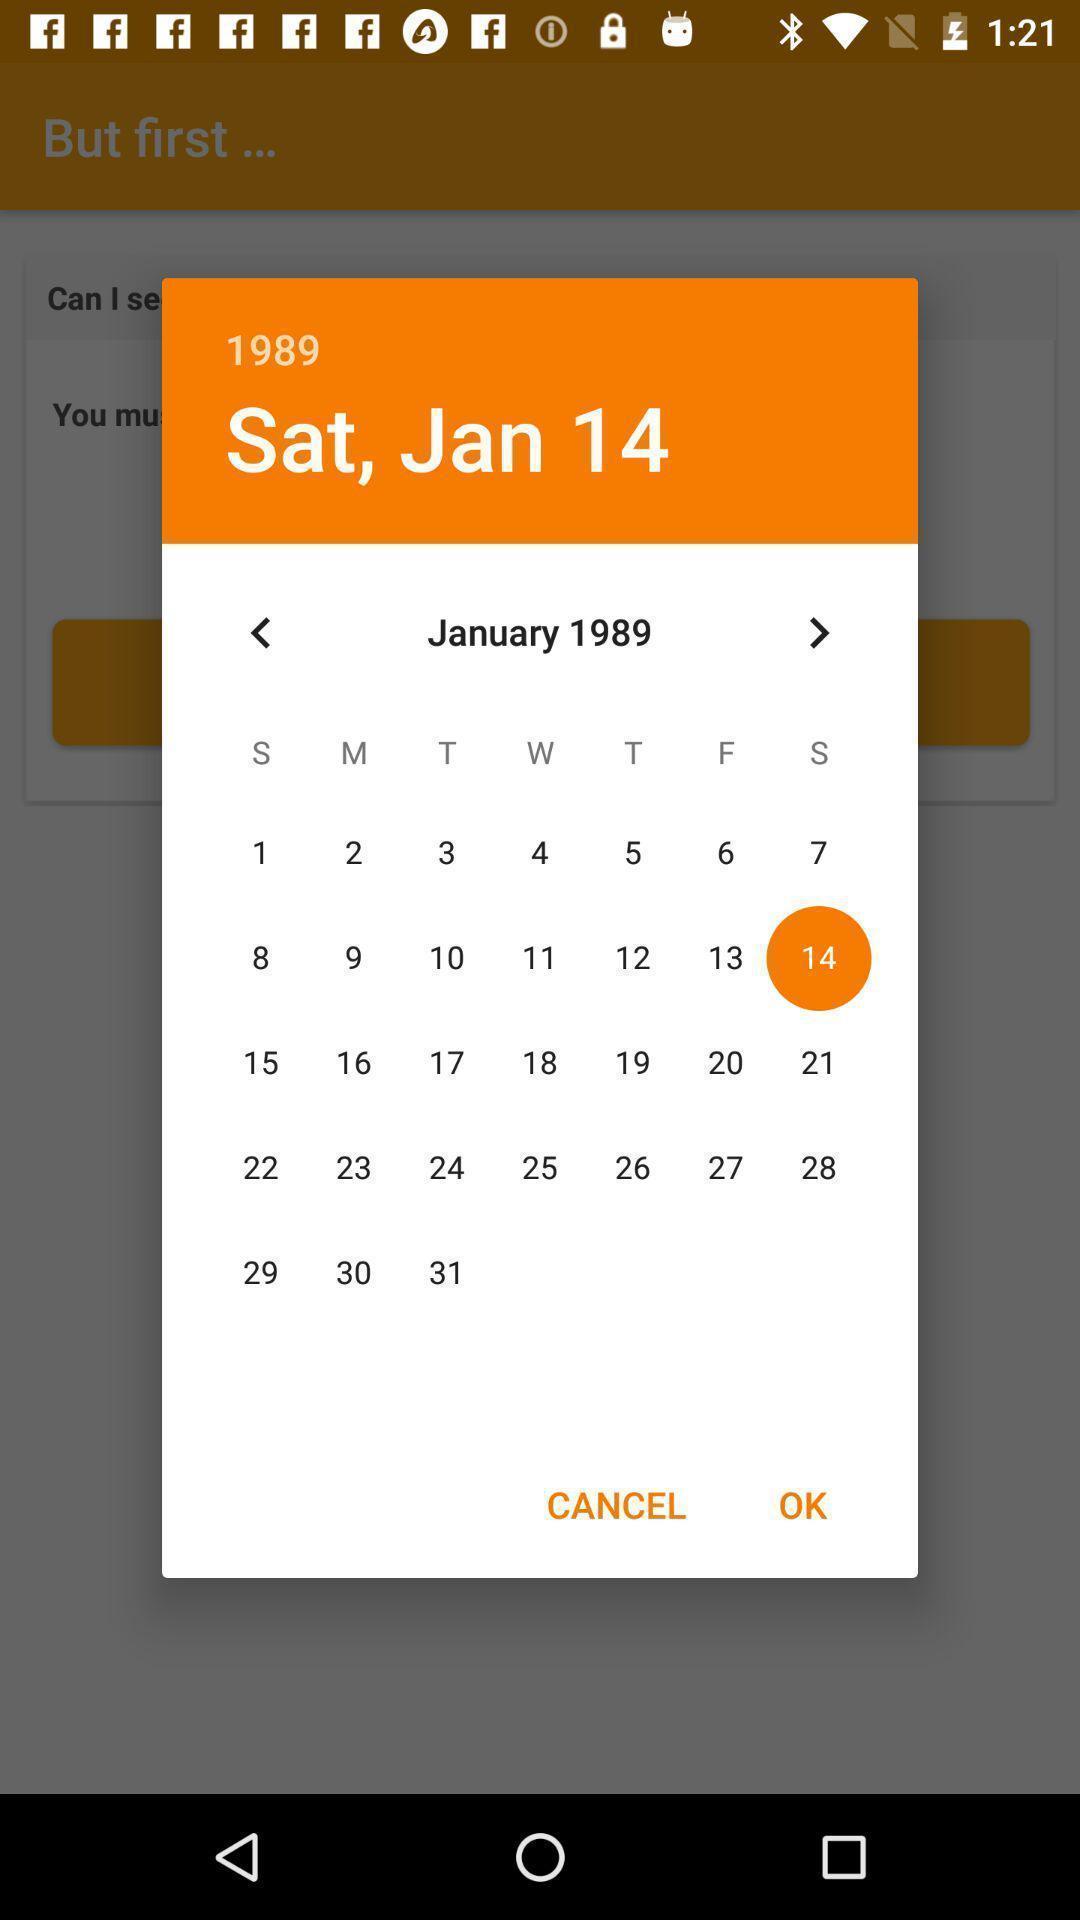What can you discern from this picture? Screen displaying a date in month calendar. 